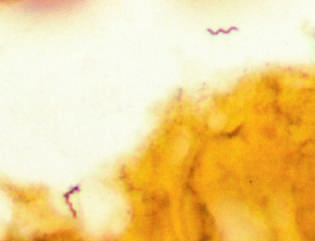s a homer-wright pseudorosette stain preparation of brain tissue from a patient with lyme disease meningoencephalitis?
Answer the question using a single word or phrase. No 